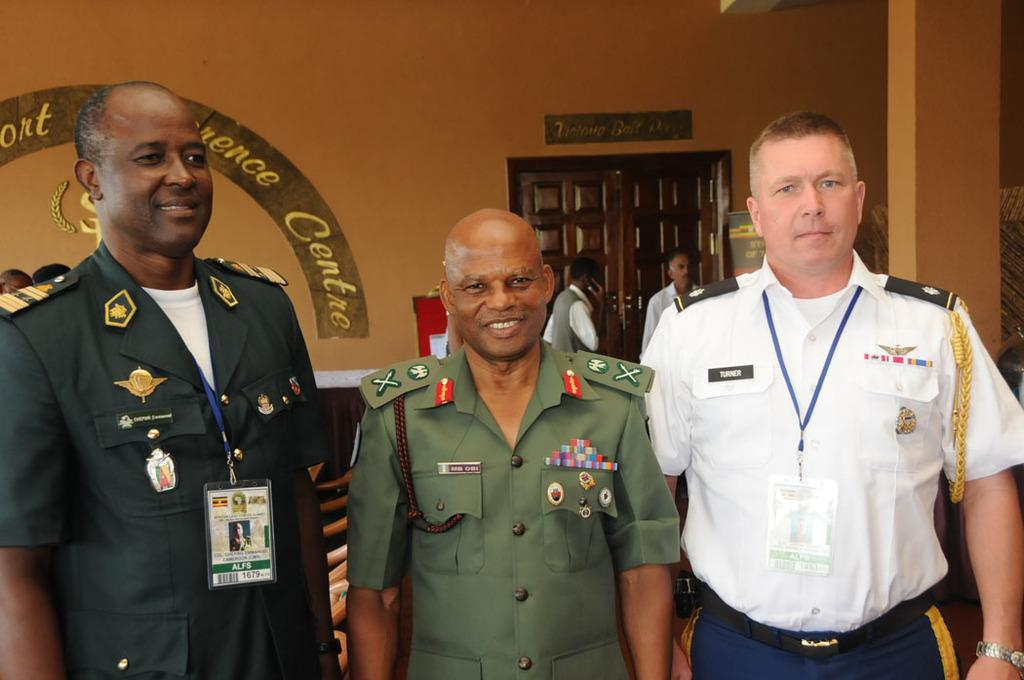What are the people in the image doing? The persons standing in the image are smiling. Can you describe the background of the image? There is text written on a wall in the background, and there is a door in the background as well. Are there any other people visible in the image? Yes, there are additional persons in the background. How many horses can be seen in the image? There are no horses present in the image. What color is the tooth of the person in the image? There is no tooth visible in the image, as it focuses on people standing and smiling. 